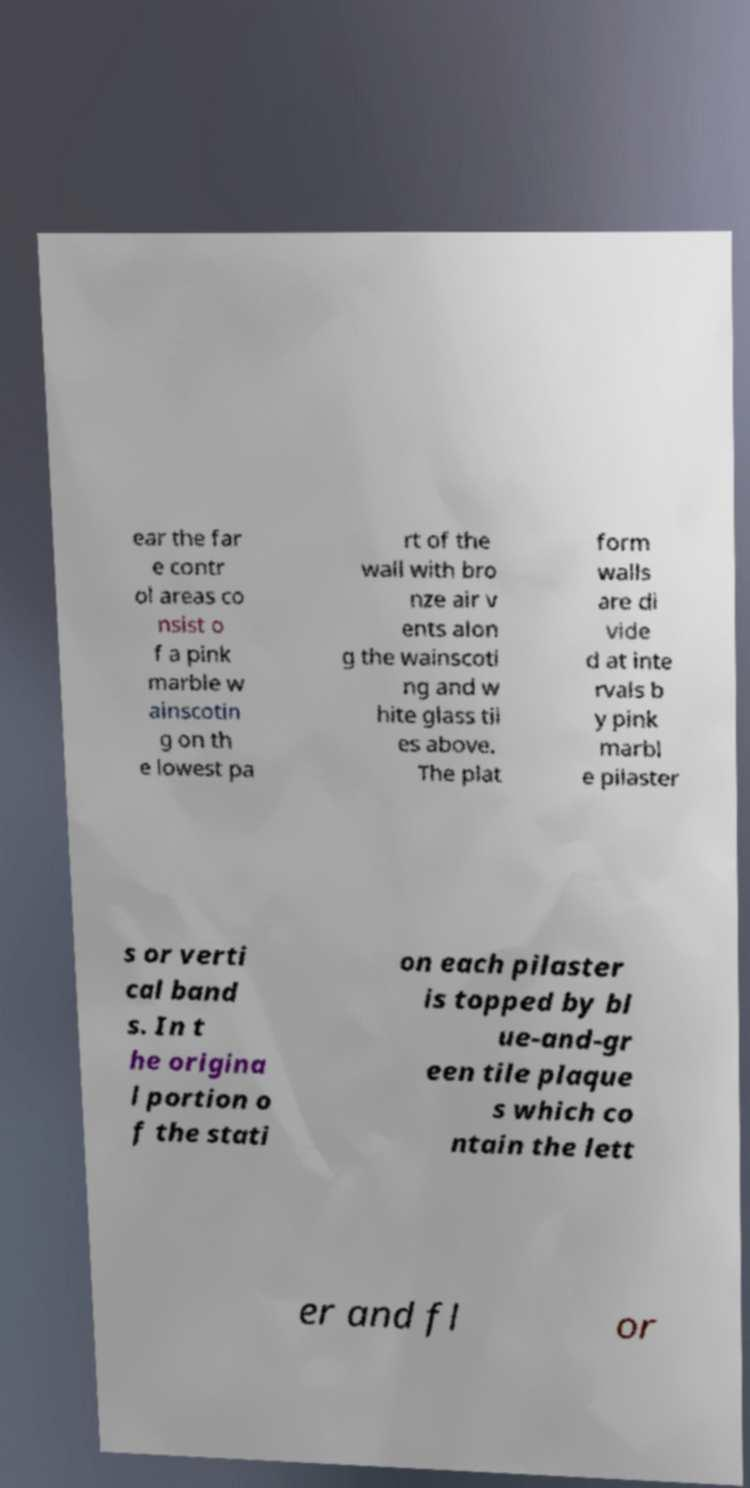Please read and relay the text visible in this image. What does it say? ear the far e contr ol areas co nsist o f a pink marble w ainscotin g on th e lowest pa rt of the wall with bro nze air v ents alon g the wainscoti ng and w hite glass til es above. The plat form walls are di vide d at inte rvals b y pink marbl e pilaster s or verti cal band s. In t he origina l portion o f the stati on each pilaster is topped by bl ue-and-gr een tile plaque s which co ntain the lett er and fl or 